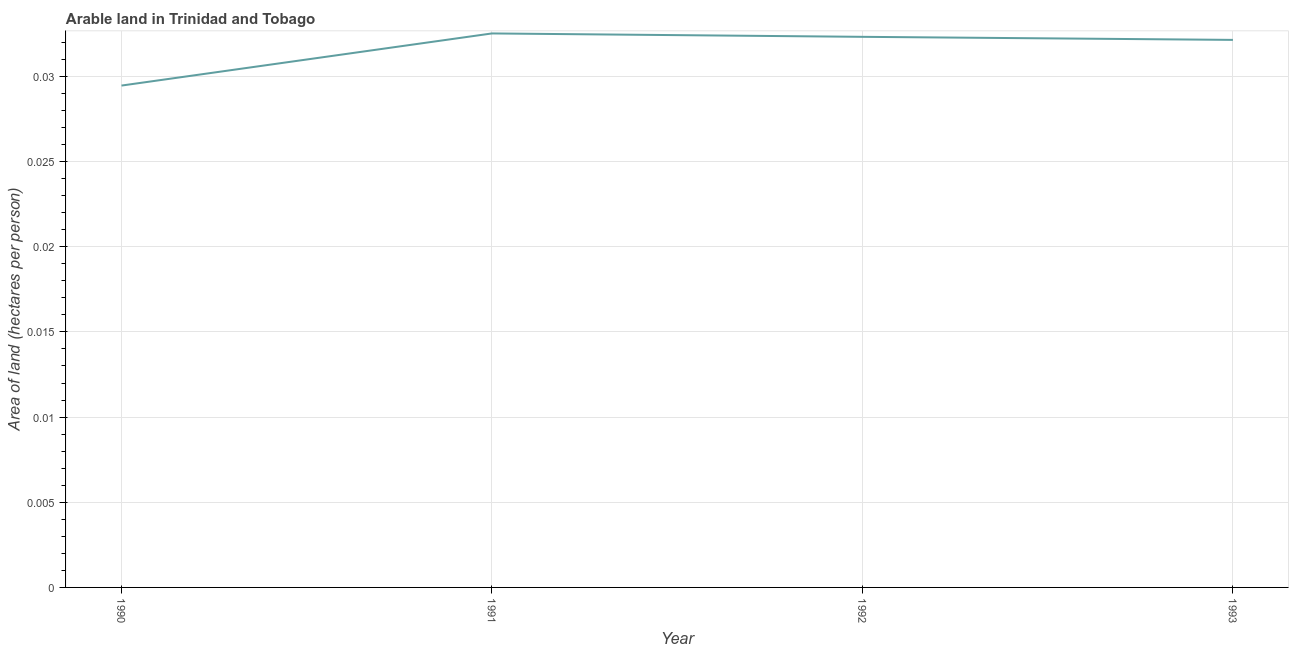What is the area of arable land in 1992?
Ensure brevity in your answer.  0.03. Across all years, what is the maximum area of arable land?
Make the answer very short. 0.03. Across all years, what is the minimum area of arable land?
Your answer should be very brief. 0.03. In which year was the area of arable land maximum?
Offer a terse response. 1991. In which year was the area of arable land minimum?
Ensure brevity in your answer.  1990. What is the sum of the area of arable land?
Offer a terse response. 0.13. What is the difference between the area of arable land in 1991 and 1992?
Offer a terse response. 0. What is the average area of arable land per year?
Ensure brevity in your answer.  0.03. What is the median area of arable land?
Provide a succinct answer. 0.03. Do a majority of the years between 1990 and 1992 (inclusive) have area of arable land greater than 0.022 hectares per person?
Offer a very short reply. Yes. What is the ratio of the area of arable land in 1991 to that in 1992?
Your answer should be compact. 1.01. Is the difference between the area of arable land in 1992 and 1993 greater than the difference between any two years?
Provide a succinct answer. No. What is the difference between the highest and the second highest area of arable land?
Provide a short and direct response. 0. Is the sum of the area of arable land in 1991 and 1993 greater than the maximum area of arable land across all years?
Offer a very short reply. Yes. What is the difference between the highest and the lowest area of arable land?
Your answer should be very brief. 0. How many years are there in the graph?
Your response must be concise. 4. What is the difference between two consecutive major ticks on the Y-axis?
Your answer should be very brief. 0.01. What is the title of the graph?
Give a very brief answer. Arable land in Trinidad and Tobago. What is the label or title of the Y-axis?
Give a very brief answer. Area of land (hectares per person). What is the Area of land (hectares per person) of 1990?
Your answer should be very brief. 0.03. What is the Area of land (hectares per person) in 1991?
Your response must be concise. 0.03. What is the Area of land (hectares per person) of 1992?
Offer a terse response. 0.03. What is the Area of land (hectares per person) of 1993?
Ensure brevity in your answer.  0.03. What is the difference between the Area of land (hectares per person) in 1990 and 1991?
Your answer should be very brief. -0. What is the difference between the Area of land (hectares per person) in 1990 and 1992?
Provide a succinct answer. -0. What is the difference between the Area of land (hectares per person) in 1990 and 1993?
Your response must be concise. -0. What is the difference between the Area of land (hectares per person) in 1991 and 1993?
Ensure brevity in your answer.  0. What is the difference between the Area of land (hectares per person) in 1992 and 1993?
Offer a very short reply. 0. What is the ratio of the Area of land (hectares per person) in 1990 to that in 1991?
Offer a very short reply. 0.91. What is the ratio of the Area of land (hectares per person) in 1990 to that in 1992?
Provide a succinct answer. 0.91. What is the ratio of the Area of land (hectares per person) in 1990 to that in 1993?
Offer a very short reply. 0.92. What is the ratio of the Area of land (hectares per person) in 1991 to that in 1993?
Provide a succinct answer. 1.01. What is the ratio of the Area of land (hectares per person) in 1992 to that in 1993?
Your response must be concise. 1.01. 